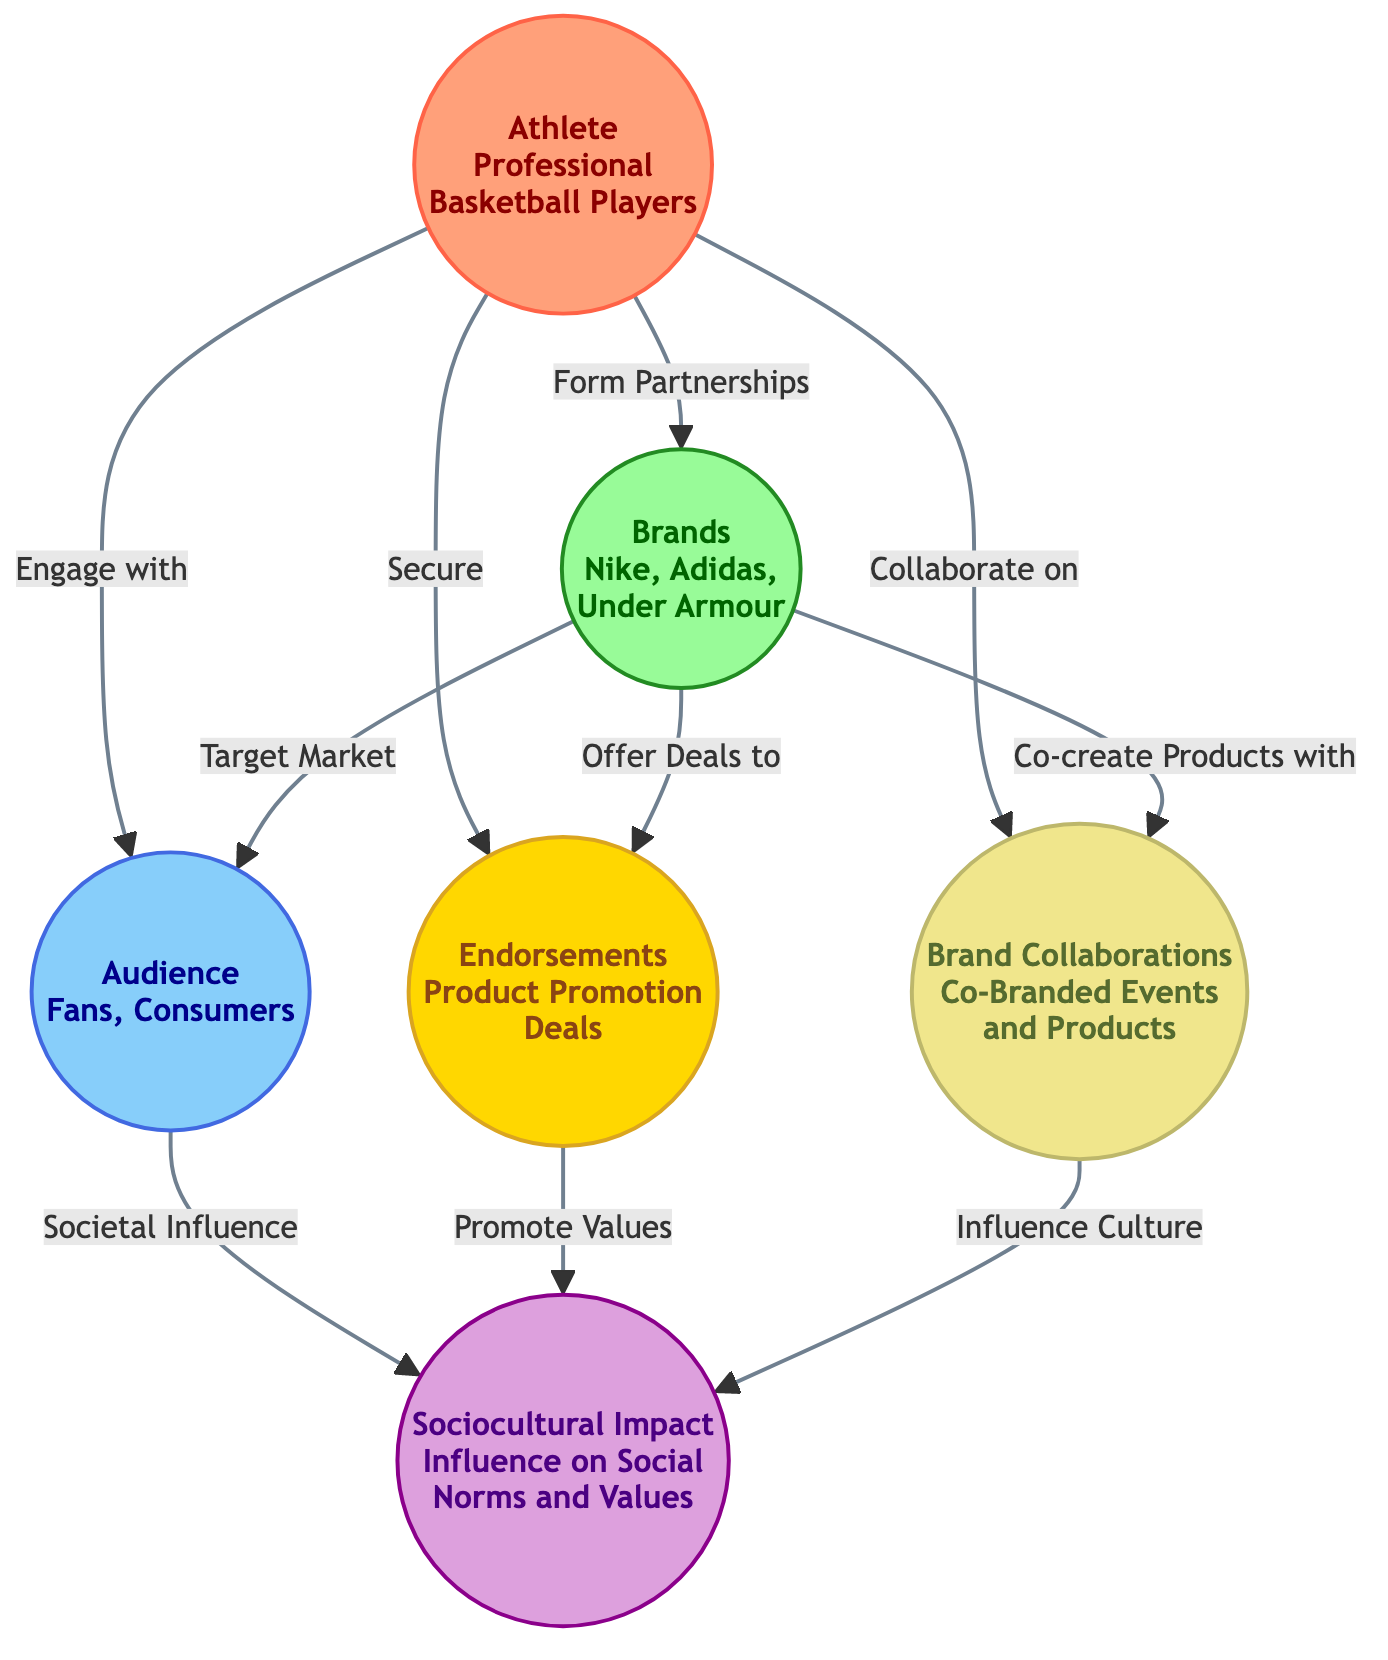What are the main entities represented in the diagram? The diagram includes six main entities: Athlete, Brands, Audience, Sociocultural Impact, Endorsements, and Brand Collaborations. Each entity influences others and is connected through various relationships, but these six are the key components of the sociocultural dimensions discussed.
Answer: Athlete, Brands, Audience, Sociocultural Impact, Endorsements, Brand Collaborations How many relationships does the Athlete have with other nodes? The Athlete node connects to four other nodes: Brands, Audience, Endorsements, and Brand Collaborations. Counting these outgoing connections gives us a total of four relationships from the Athlete node.
Answer: 4 Which brands are represented in the diagram? The brands highlighted in the diagram include Nike, Adidas, and Under Armour. These brands represent the products and services that could be endorsed or collaborated on by the athletes, and they are specifically listed under the Brands node.
Answer: Nike, Adidas, Under Armour What influence does the Audience have in the diagram? The Audience influences sociocultural impacts as indicated by the arrow from the Audience node to the Sociocultural Impact node. This shows that the audience's preferences and values can shape and reflect social norms and values in society.
Answer: Societal Influence What is the relationship between Endorsements and Sociocultural Impact? The relationship here is that Endorsements promote values which in turn influence Sociocultural Impact. The diagram indicates that through product promotions, athletes convey messages and values that resonate with society, thus impacting social norms and values.
Answer: Promote Values How do Brands engage with the Audience? Brands engage with the Audience by targeting them as their market. The arrow connecting the Brands node to the Audience node indicates that brands tailor their marketing strategies to appeal specifically to fans and consumers.
Answer: Target Market What is the general aim of Brand Collaborations in the context of the diagram? The general aim of Brand Collaborations is to influence culture through co-branded events and products. This collaboration allows athletes and brands to create joint ventures that resonate with the societal values and preferences of the audience.
Answer: Influence Culture What role do endorsements play in relation to sociocultural values? Endorsements play a crucial role in promoting values that can shape sociocultural norms. The link from Endorsements to Sociocultural Impact implies that the products endorsed not only influence purchasing decisions but also embody and reflect larger cultural values.
Answer: Promote Values 